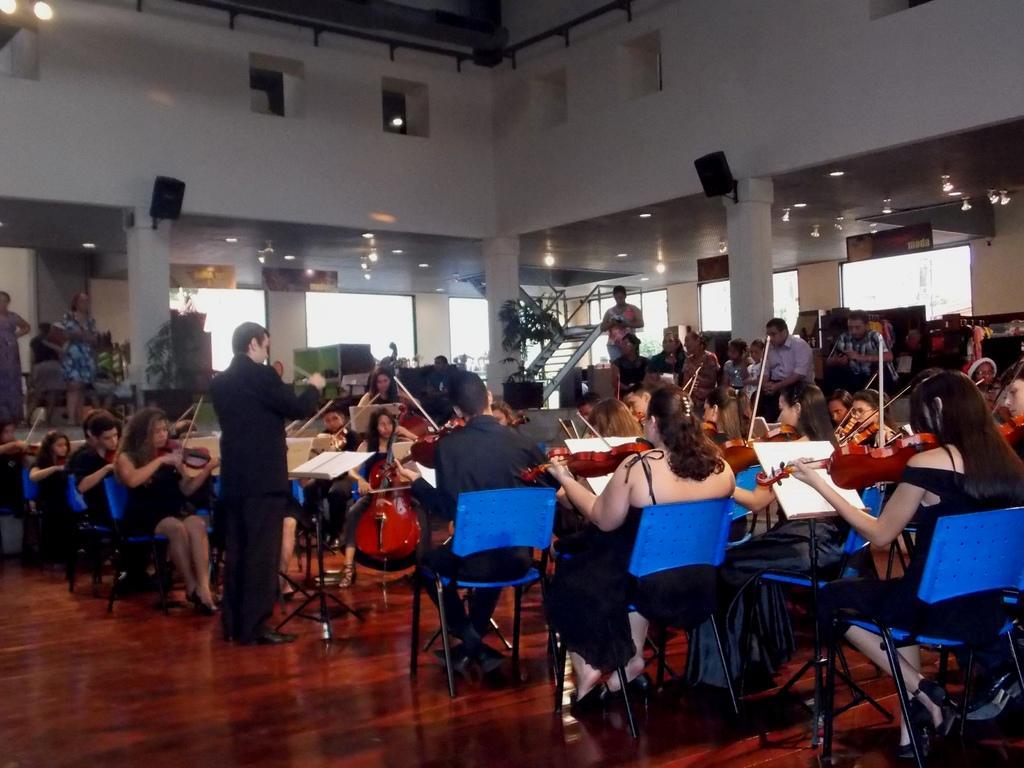Can you describe this image briefly? There is one person standing and wearing a black color dress on the left side of this image. We can see people sitting on the chairs and playing violin. There are pillars and a wall in the background. 